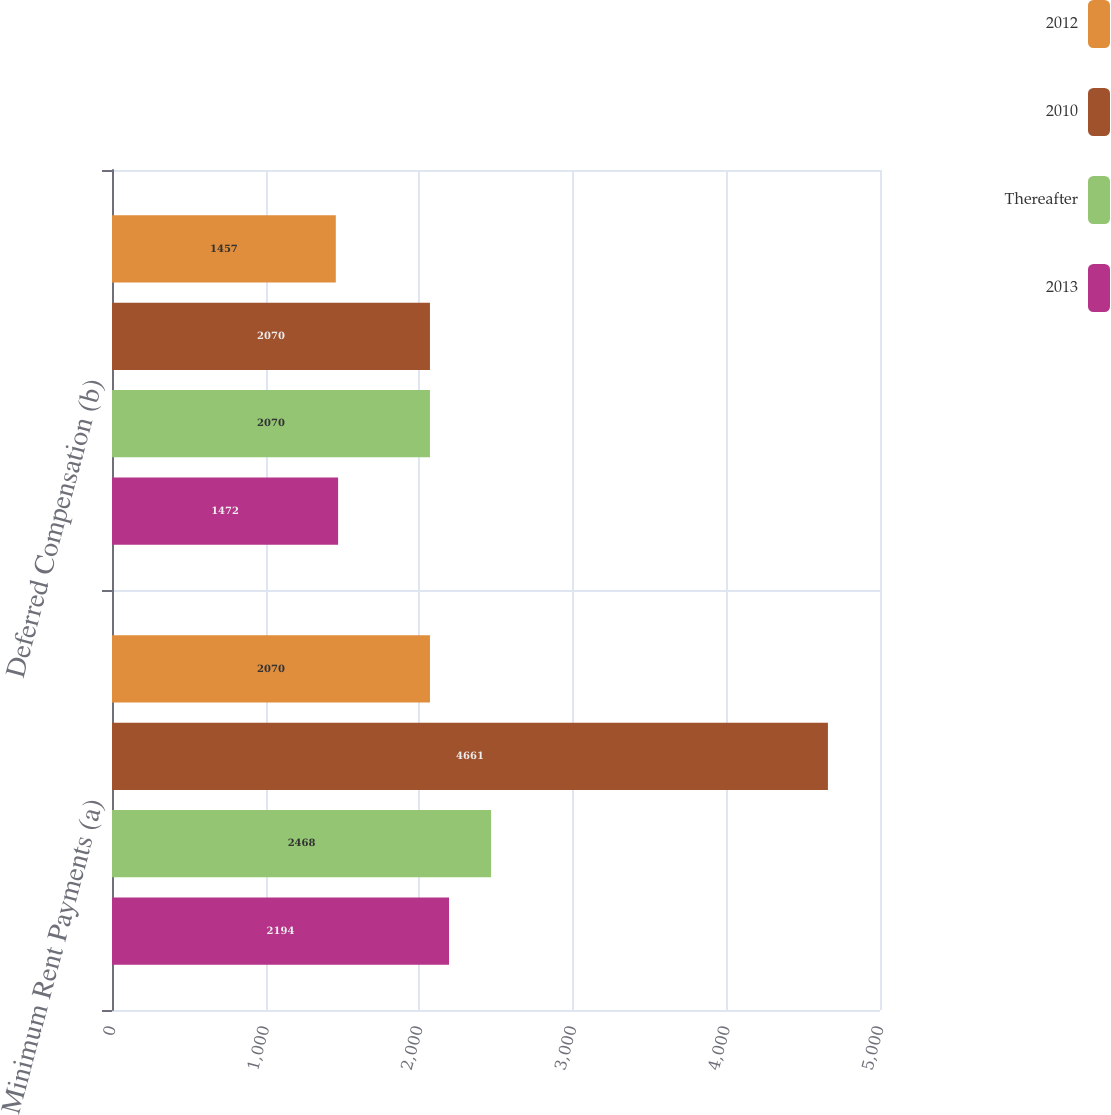<chart> <loc_0><loc_0><loc_500><loc_500><stacked_bar_chart><ecel><fcel>Minimum Rent Payments (a)<fcel>Deferred Compensation (b)<nl><fcel>2012<fcel>2070<fcel>1457<nl><fcel>2010<fcel>4661<fcel>2070<nl><fcel>Thereafter<fcel>2468<fcel>2070<nl><fcel>2013<fcel>2194<fcel>1472<nl></chart> 